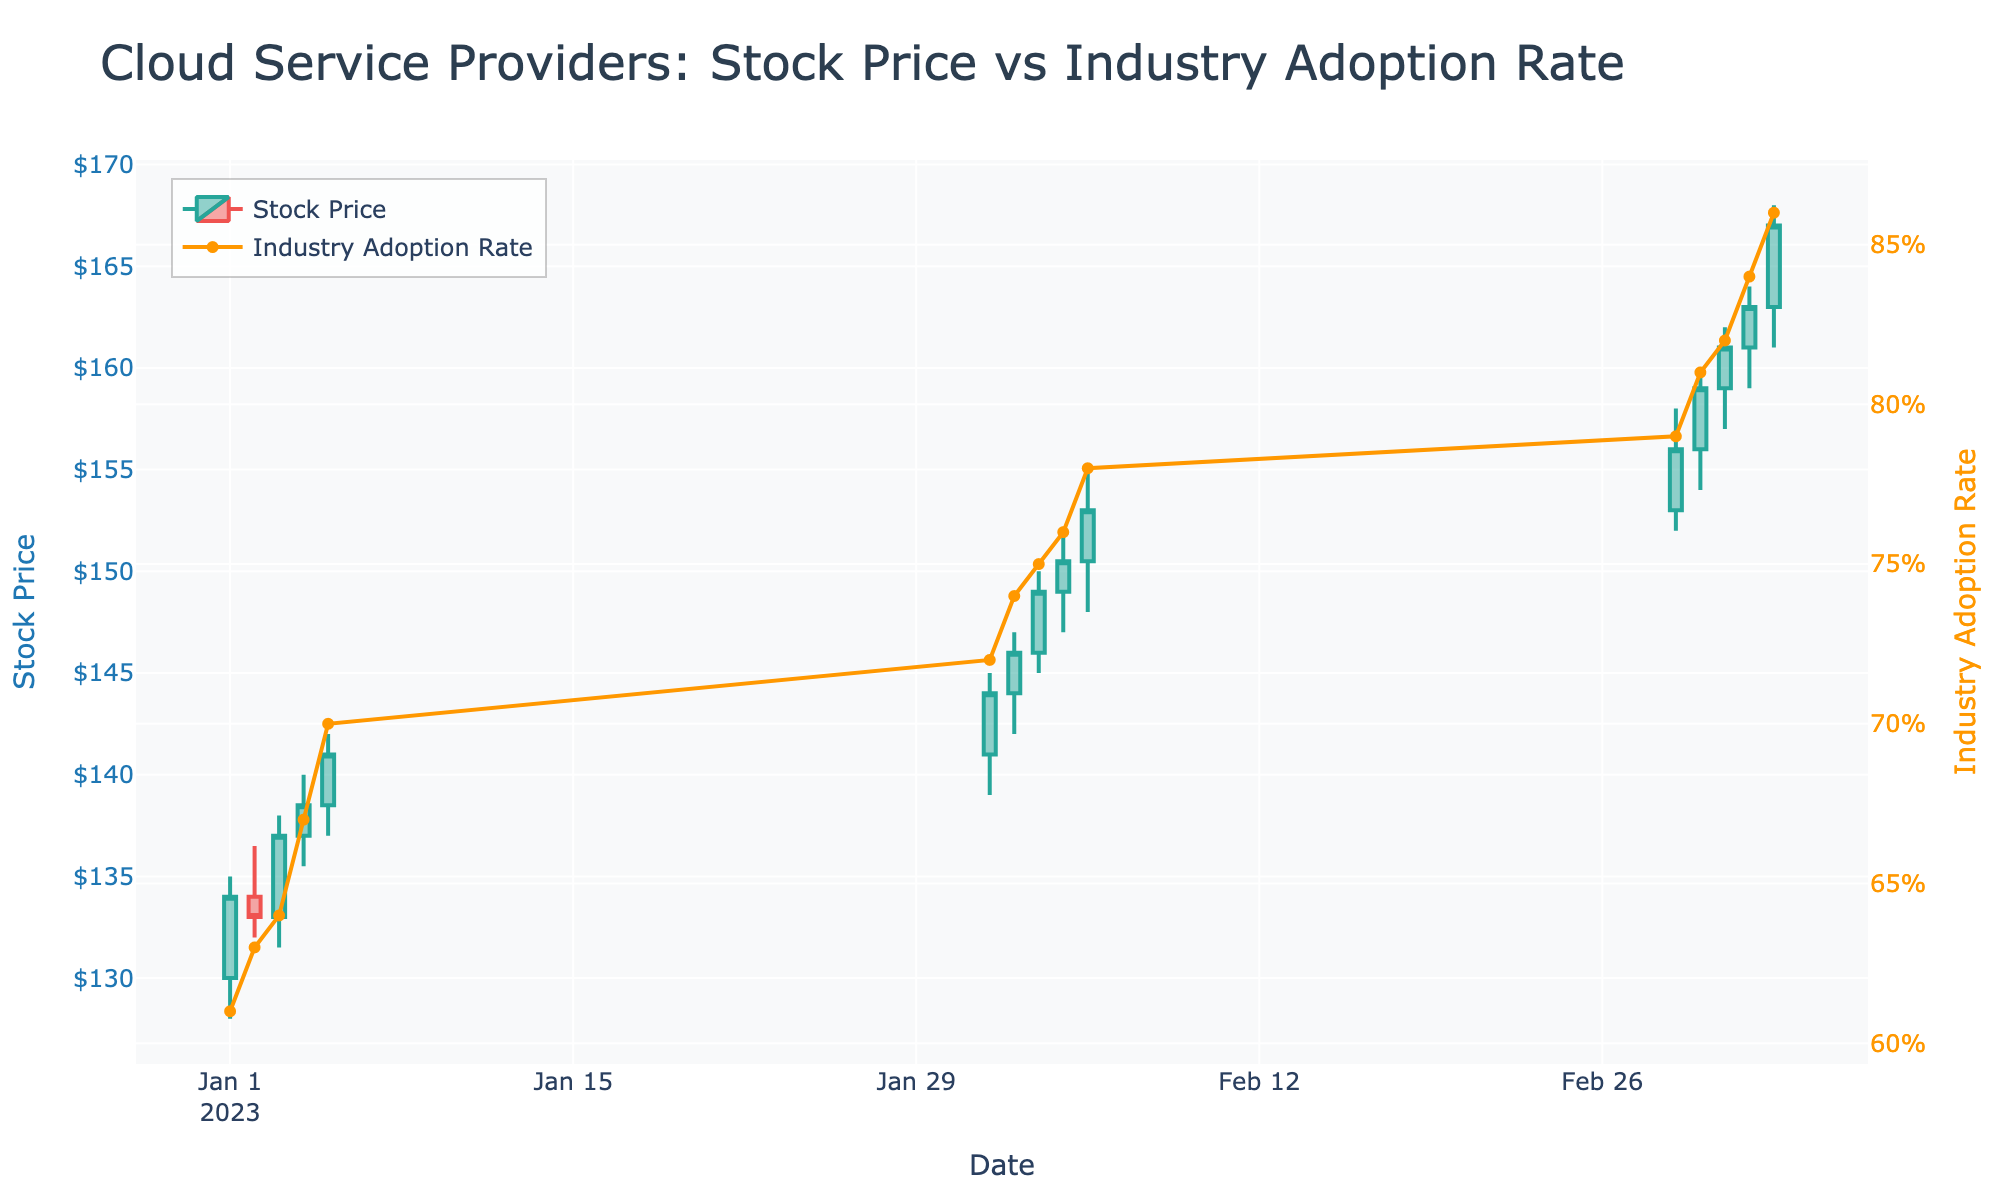What is the title of the figure? The title is displayed at the top of the figure. From the figure, we can see it reads "Cloud Service Providers: Stock Price vs Industry Adoption Rate".
Answer: Cloud Service Providers: Stock Price vs Industry Adoption Rate What is the highest stock price recorded in the figure? The highest stock price is the peak of the candlestick high values. In this figure, it is $168, recorded on March 5, 2023.
Answer: $168 On which date did the stock close at its lowest point? We need to look for the candlestick with the lowest closing value. The lowest closing price is $133, occurring on January 2, 2023.
Answer: January 2, 2023 How many data points are represented in the figure? The number of candlesticks corresponds to the number of dates listed. Counting these, we get a total of 15 data points.
Answer: 15 How does the stock price trend compare to the industry adoption rate from January to March? Analyzing both the candlestick plot (for stock price) and the line plot (for industry adoption rate), we see that both the stock price and adoption rate show an overall upward trend. Starting at $134 on January 1, and closing at $167 on March 5, with adoption rates increasing from 0.61 to 0.86.
Answer: Both upward trends Between which dates did the stock price experience the sharpest increase in closing value? To determine the sharpest increase, look at the differences in consecutive closing prices. From January 5 ($141) to February 1 ($144), there's a notable increase, but the sharpest is between January 3 ($137) and January 4 ($138.50).
Answer: January 3 to January 4 What color represents the increasing trend in the candlestick plot? The color indicating an increasing trend is visually identified by green or a similar color depending on the plotting color scheme. Here, it is a teal-like color.
Answer: Teal (or green) What was the stock's trading volume on January 3, 2023? Trading volume is shown as part of the data, correlated with the respective date. On January 3, 2023, the trading volume was 2,000,000.
Answer: 2,000,000 How does the adoption rate on February 5, 2023 compare to January 5, 2023? The adoption rate on February 5, 2023 (0.78) needs to be compared to January 5, 2023 (0.70). The adoption rate increased by 0.08.
Answer: 0.78 is greater than 0.70 Which month saw the highest increase in industry adoption rate? Comparing the start and end values of each month: January (0.61 to 0.70 = 0.09), February (0.70 to 0.78 = 0.08), March (0.79 to 0.86 = 0.07), January saw the highest increase.
Answer: January 